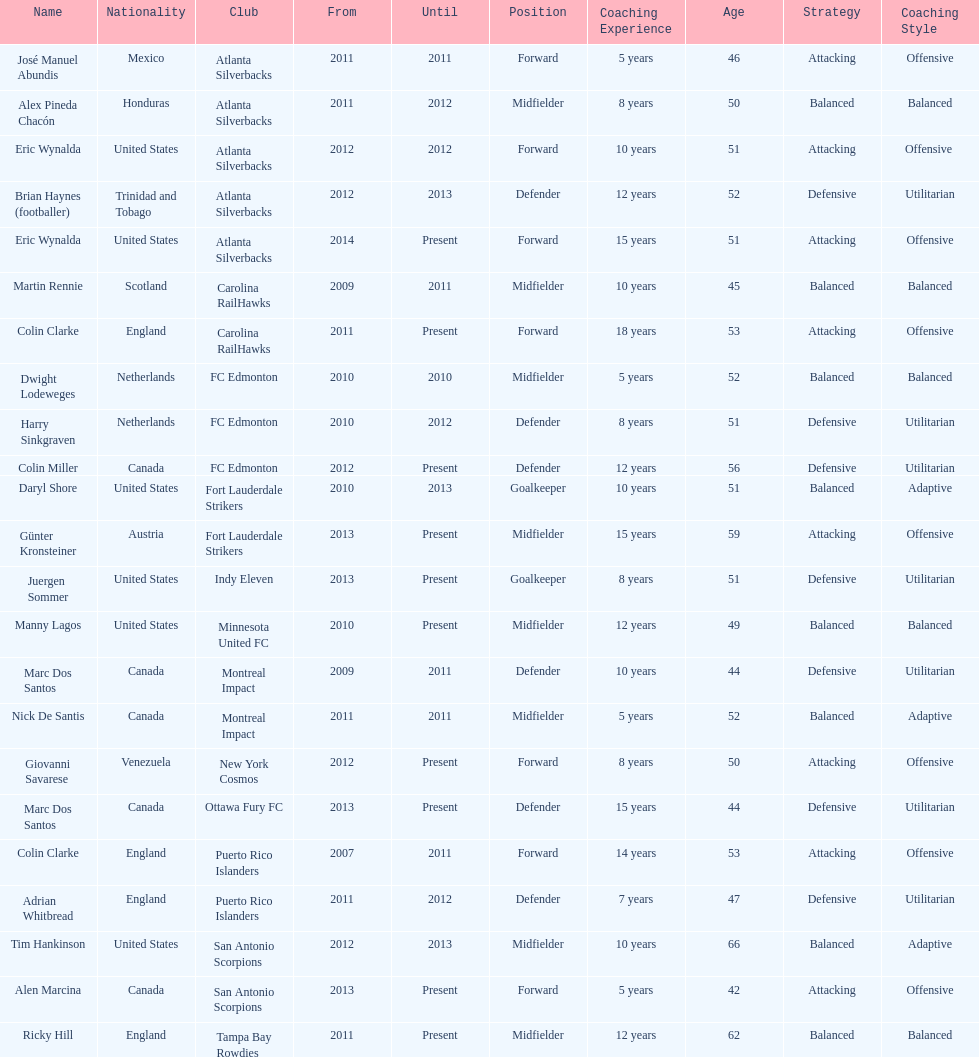Who coached the silverbacks longer, abundis or chacon? Chacon. 